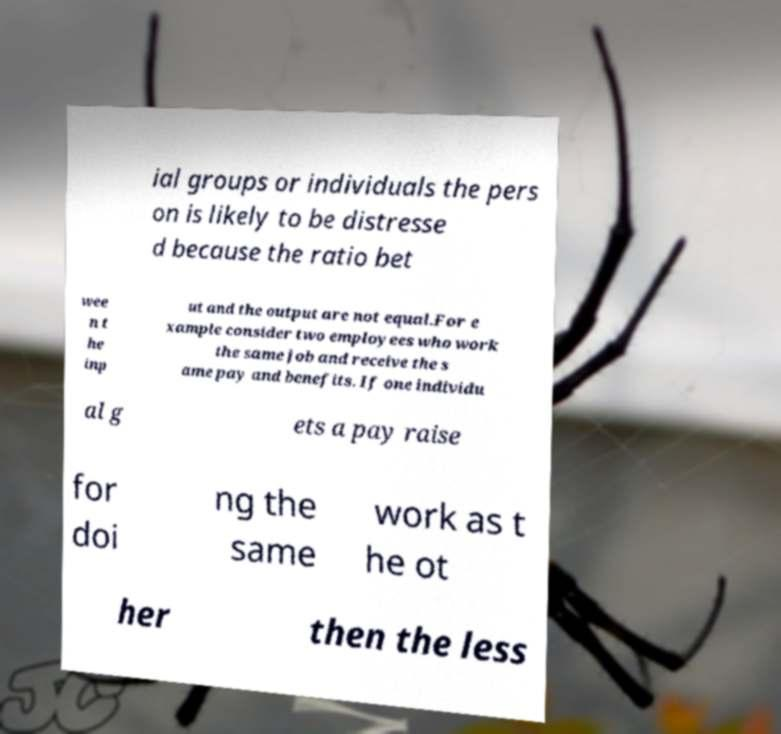Can you accurately transcribe the text from the provided image for me? ial groups or individuals the pers on is likely to be distresse d because the ratio bet wee n t he inp ut and the output are not equal.For e xample consider two employees who work the same job and receive the s ame pay and benefits. If one individu al g ets a pay raise for doi ng the same work as t he ot her then the less 